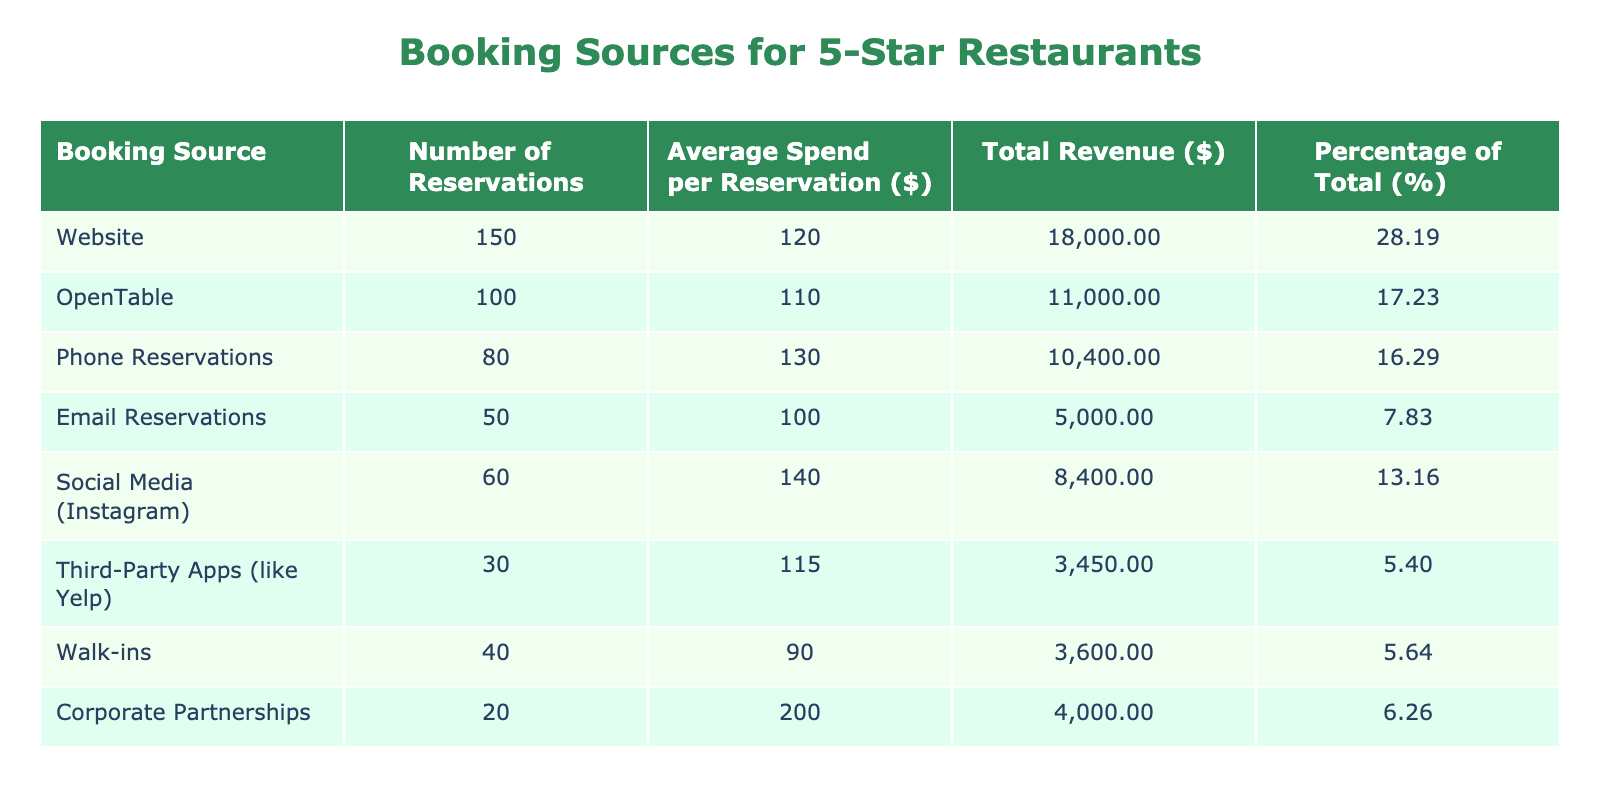What is the total number of reservations made via the website? The table shows that the number of reservations made via the website is recorded as 150.
Answer: 150 Which booking source has the highest average spend per reservation? By comparing the average spend per reservation for each booking source, Corporate Partnerships has the highest value at 200.
Answer: Corporate Partnerships How many reservations were made through OpenTable compared to Email Reservations? OpenTable had 100 reservations, while Email Reservations had 50. Therefore, OpenTable had 50 more reservations than Email Reservations (100 - 50 = 50).
Answer: 50 What is the combined number of reservations made through Social Media and Third-Party Apps? The number of reservations for Social Media is 60 and for Third-Party Apps is 30. Adding these together gives 60 + 30 = 90.
Answer: 90 Is the average spend per reservation for Walk-ins greater than that of Email Reservations? The average spend per reservation for Walk-ins is 90, and for Email Reservations, it is 100. Since 90 is less than 100, the statement is false.
Answer: No What percentage of the total revenue is generated from Corporate Partnerships? First, we need to calculate the total revenue generated by Corporate Partnerships, which is 20 reservations times 200 dollars, equaling 4000 dollars. The total revenue from all sources is calculated as the sum of all individual revenues. Corporate Partnerships' contribution is then (4000 / total revenue) * 100%. The total revenue amounts to 20,700 dollars; therefore, Corporate Partnerships accounts for (4000 / 20700) * 100% = 19.31%.
Answer: 19.31% Which booking source contributed to the least total revenue? To find this, we calculate total revenue for each source: Website (18000), OpenTable (11000), Phone Reservations (10400), Email Reservations (5000), Social Media (8400), Third-Party Apps (3450), Walk-ins (3600), Corporate Partnerships (4000). The lowest is Third-Party Apps at 3450.
Answer: Third-Party Apps How much more revenue does the website generate compared to Walk-ins? The total revenue from the website is 18000 and from Walk-ins is 3600. To find the difference, we subtract 3600 from 18000, giving us 14400.
Answer: 14400 What would be the average spend per reservation if we consider only the top three booking sources? The top three booking sources by number of reservations are Website (120), OpenTable (110), and Phone Reservations (130). To find the average spend, we calculate the total spend for these and divide by their respective reservations: (120 * 120 + 100 * 110 + 80 * 130) / (150 + 100 + 80) = (14400 + 11000 + 10400) / 330 = 11600 / 330 = 117.58.
Answer: 117.58 